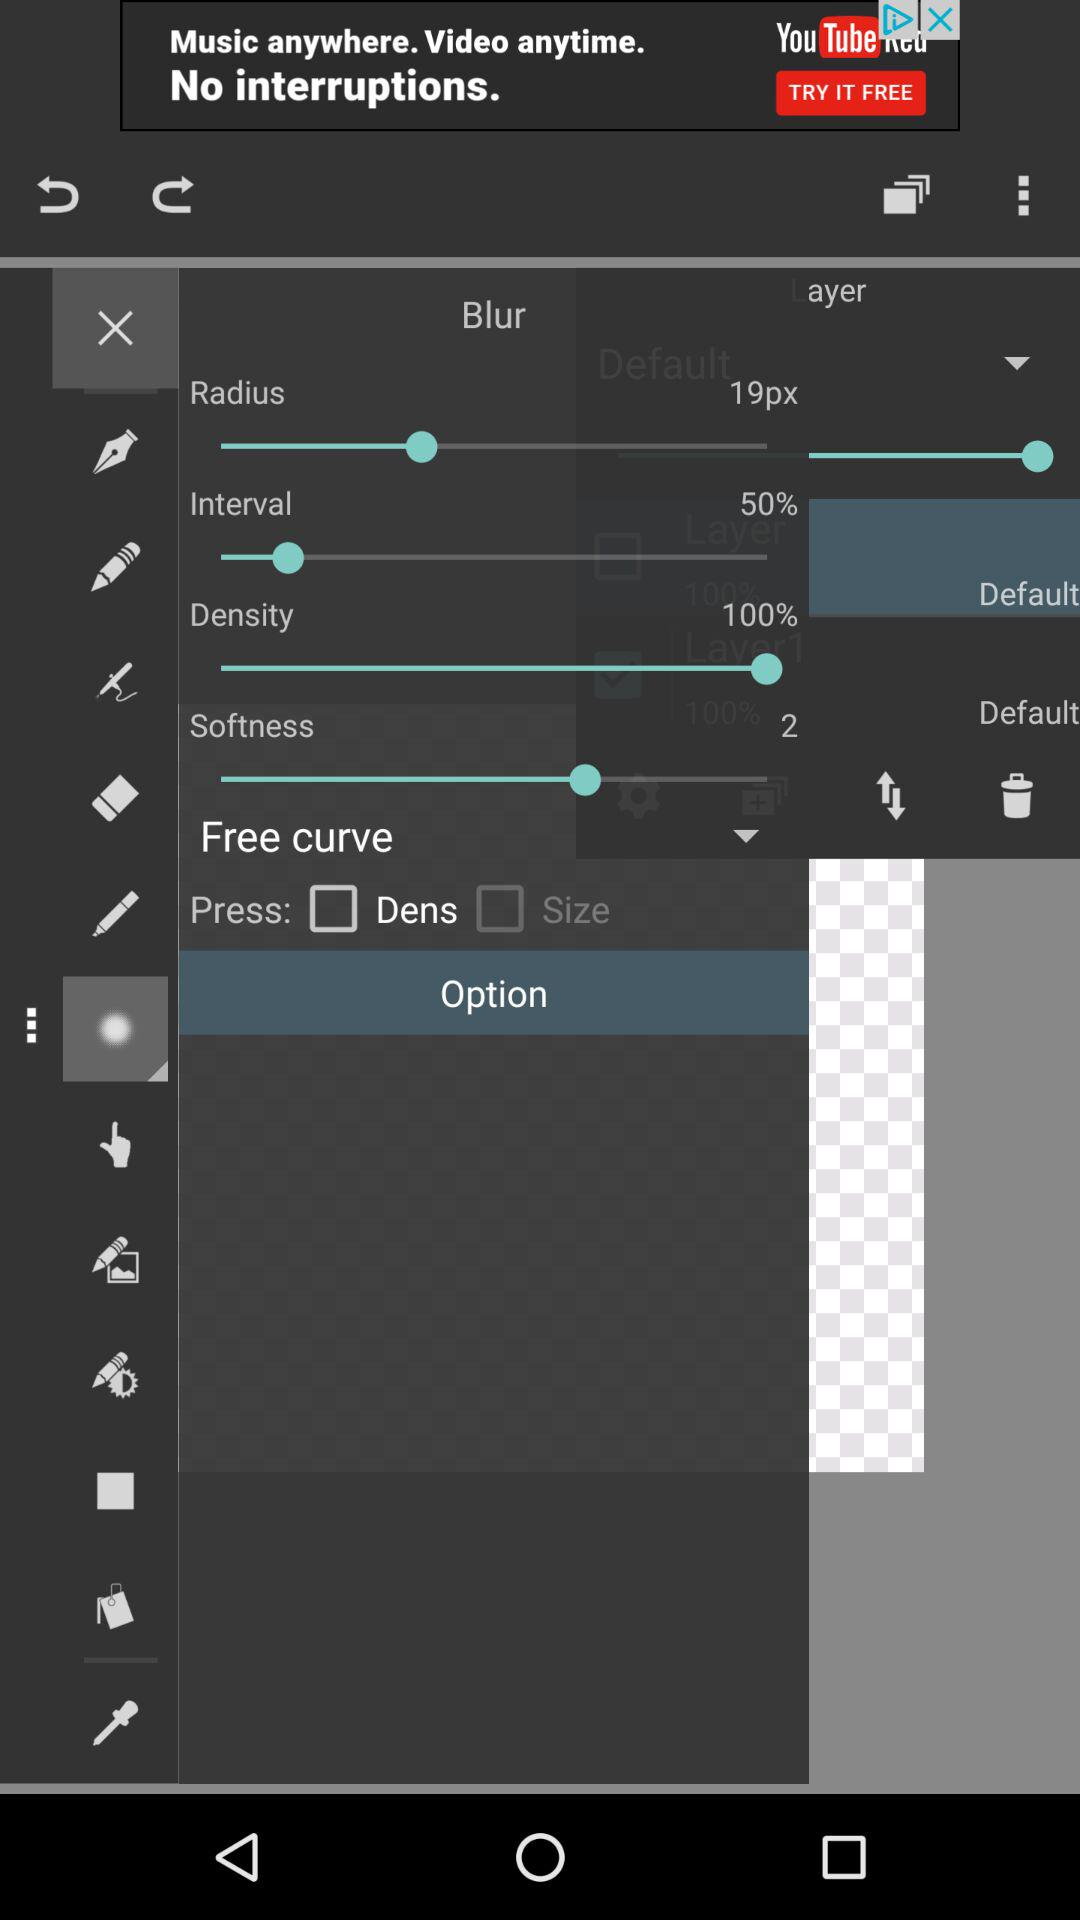What is the set value for radius? The set value is 19 pixels. 